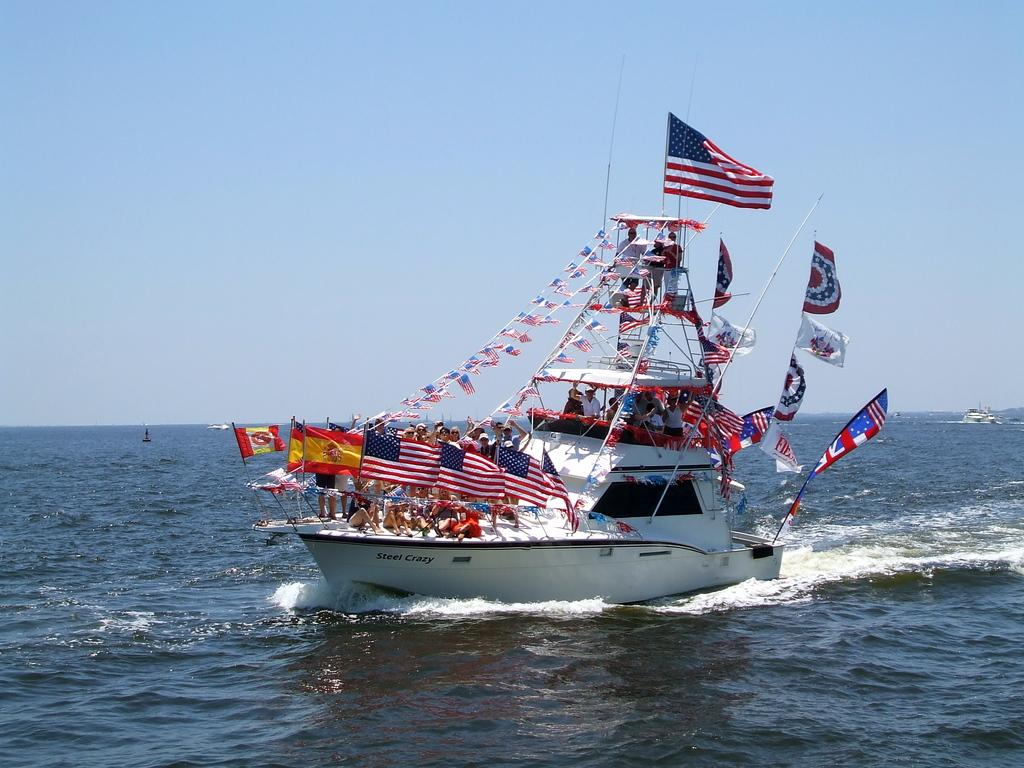<image>
Give a short and clear explanation of the subsequent image. the words steel crazy that is on a boat 